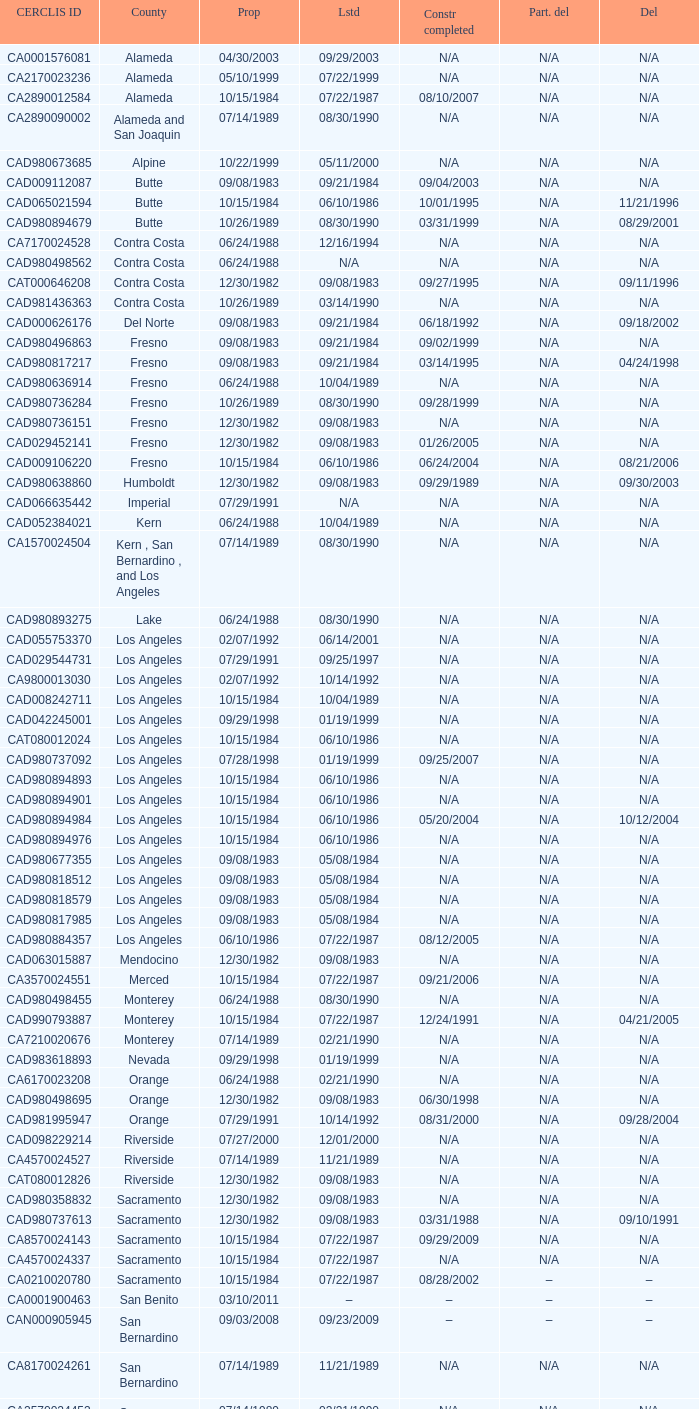What construction completed on 08/10/2007? 07/22/1987. 